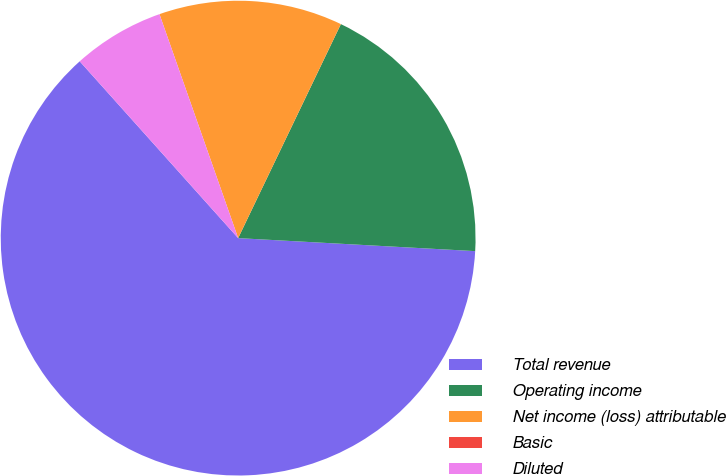Convert chart. <chart><loc_0><loc_0><loc_500><loc_500><pie_chart><fcel>Total revenue<fcel>Operating income<fcel>Net income (loss) attributable<fcel>Basic<fcel>Diluted<nl><fcel>62.5%<fcel>18.75%<fcel>12.5%<fcel>0.0%<fcel>6.25%<nl></chart> 